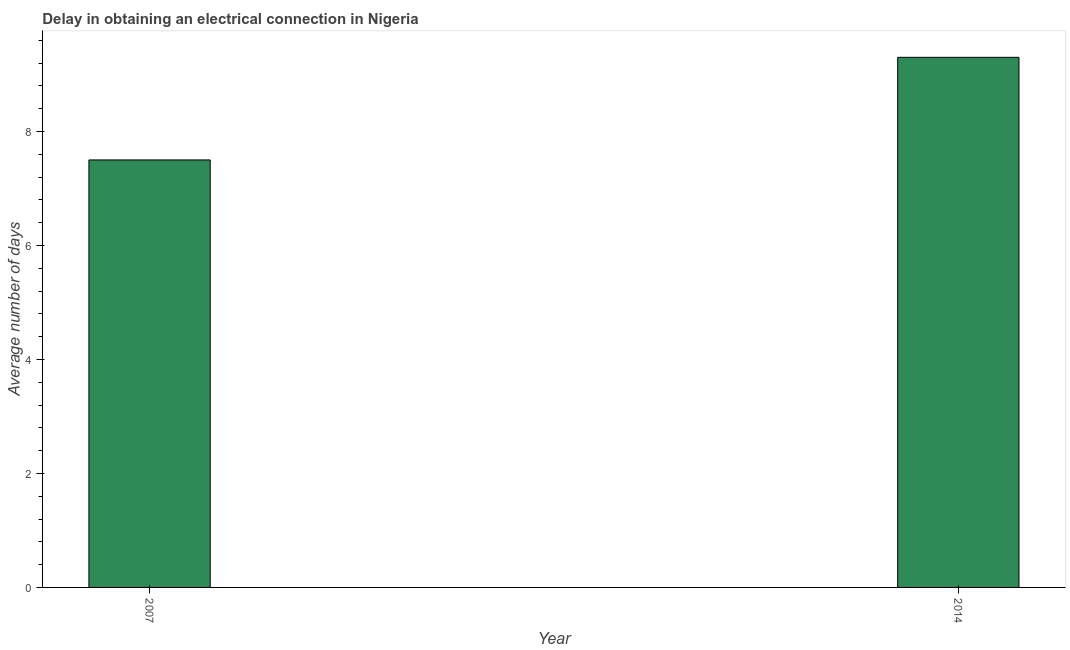Does the graph contain any zero values?
Provide a short and direct response. No. What is the title of the graph?
Your answer should be compact. Delay in obtaining an electrical connection in Nigeria. What is the label or title of the X-axis?
Give a very brief answer. Year. What is the label or title of the Y-axis?
Give a very brief answer. Average number of days. What is the dalay in electrical connection in 2014?
Ensure brevity in your answer.  9.3. Across all years, what is the maximum dalay in electrical connection?
Provide a succinct answer. 9.3. Across all years, what is the minimum dalay in electrical connection?
Your answer should be compact. 7.5. In which year was the dalay in electrical connection maximum?
Offer a terse response. 2014. In which year was the dalay in electrical connection minimum?
Ensure brevity in your answer.  2007. What is the average dalay in electrical connection per year?
Your answer should be very brief. 8.4. What is the median dalay in electrical connection?
Offer a very short reply. 8.4. In how many years, is the dalay in electrical connection greater than 2.4 days?
Your answer should be very brief. 2. Do a majority of the years between 2014 and 2007 (inclusive) have dalay in electrical connection greater than 2 days?
Keep it short and to the point. No. What is the ratio of the dalay in electrical connection in 2007 to that in 2014?
Your answer should be compact. 0.81. Is the dalay in electrical connection in 2007 less than that in 2014?
Ensure brevity in your answer.  Yes. How many bars are there?
Make the answer very short. 2. Are all the bars in the graph horizontal?
Offer a very short reply. No. What is the difference between two consecutive major ticks on the Y-axis?
Keep it short and to the point. 2. What is the Average number of days in 2014?
Your answer should be compact. 9.3. What is the difference between the Average number of days in 2007 and 2014?
Offer a terse response. -1.8. What is the ratio of the Average number of days in 2007 to that in 2014?
Ensure brevity in your answer.  0.81. 